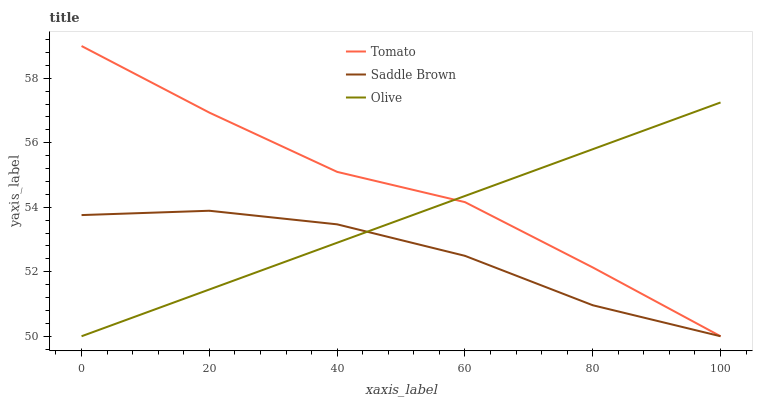Does Saddle Brown have the minimum area under the curve?
Answer yes or no. Yes. Does Tomato have the maximum area under the curve?
Answer yes or no. Yes. Does Olive have the minimum area under the curve?
Answer yes or no. No. Does Olive have the maximum area under the curve?
Answer yes or no. No. Is Olive the smoothest?
Answer yes or no. Yes. Is Tomato the roughest?
Answer yes or no. Yes. Is Saddle Brown the smoothest?
Answer yes or no. No. Is Saddle Brown the roughest?
Answer yes or no. No. Does Tomato have the lowest value?
Answer yes or no. Yes. Does Tomato have the highest value?
Answer yes or no. Yes. Does Olive have the highest value?
Answer yes or no. No. Does Saddle Brown intersect Tomato?
Answer yes or no. Yes. Is Saddle Brown less than Tomato?
Answer yes or no. No. Is Saddle Brown greater than Tomato?
Answer yes or no. No. 